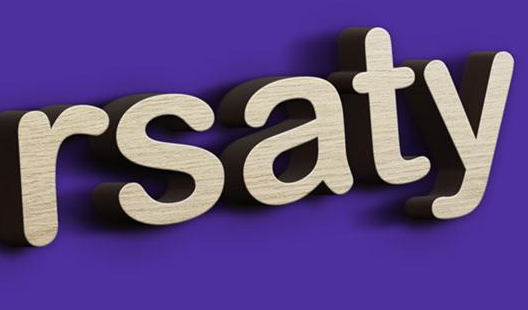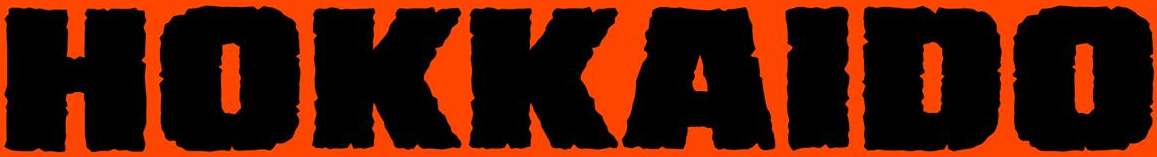What text is displayed in these images sequentially, separated by a semicolon? rsaty; HOKKAIDO 